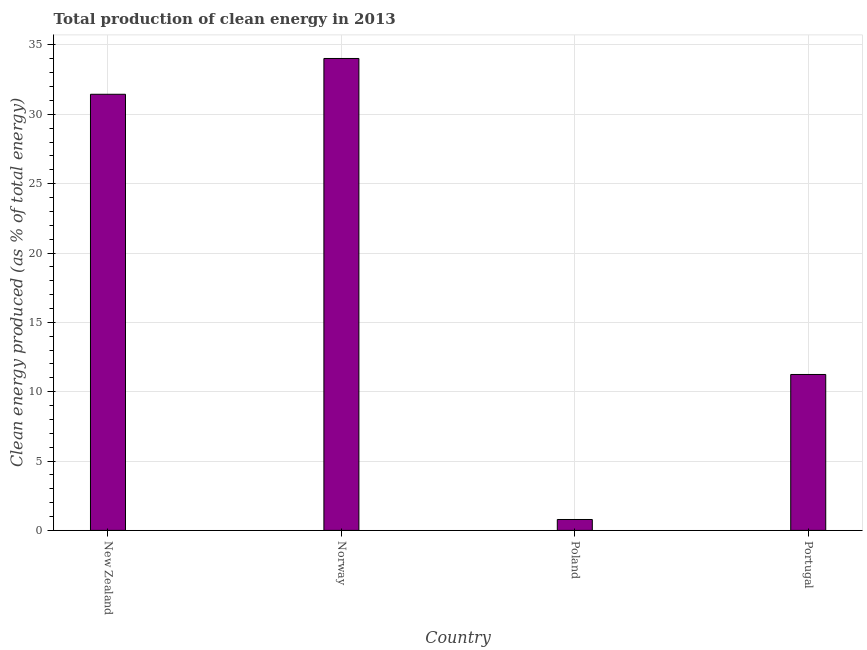What is the title of the graph?
Provide a succinct answer. Total production of clean energy in 2013. What is the label or title of the Y-axis?
Keep it short and to the point. Clean energy produced (as % of total energy). What is the production of clean energy in New Zealand?
Your response must be concise. 31.45. Across all countries, what is the maximum production of clean energy?
Your answer should be compact. 34.03. Across all countries, what is the minimum production of clean energy?
Your answer should be very brief. 0.79. What is the sum of the production of clean energy?
Give a very brief answer. 77.5. What is the difference between the production of clean energy in Norway and Poland?
Your answer should be compact. 33.24. What is the average production of clean energy per country?
Offer a very short reply. 19.38. What is the median production of clean energy?
Provide a succinct answer. 21.34. What is the ratio of the production of clean energy in New Zealand to that in Poland?
Provide a succinct answer. 39.99. Is the production of clean energy in New Zealand less than that in Poland?
Give a very brief answer. No. What is the difference between the highest and the second highest production of clean energy?
Make the answer very short. 2.58. Is the sum of the production of clean energy in New Zealand and Poland greater than the maximum production of clean energy across all countries?
Your answer should be compact. No. What is the difference between the highest and the lowest production of clean energy?
Your response must be concise. 33.24. In how many countries, is the production of clean energy greater than the average production of clean energy taken over all countries?
Your answer should be very brief. 2. How many bars are there?
Ensure brevity in your answer.  4. Are all the bars in the graph horizontal?
Offer a terse response. No. What is the Clean energy produced (as % of total energy) of New Zealand?
Provide a short and direct response. 31.45. What is the Clean energy produced (as % of total energy) in Norway?
Offer a terse response. 34.03. What is the Clean energy produced (as % of total energy) in Poland?
Your answer should be very brief. 0.79. What is the Clean energy produced (as % of total energy) of Portugal?
Ensure brevity in your answer.  11.24. What is the difference between the Clean energy produced (as % of total energy) in New Zealand and Norway?
Keep it short and to the point. -2.58. What is the difference between the Clean energy produced (as % of total energy) in New Zealand and Poland?
Keep it short and to the point. 30.66. What is the difference between the Clean energy produced (as % of total energy) in New Zealand and Portugal?
Your response must be concise. 20.2. What is the difference between the Clean energy produced (as % of total energy) in Norway and Poland?
Provide a short and direct response. 33.24. What is the difference between the Clean energy produced (as % of total energy) in Norway and Portugal?
Your answer should be very brief. 22.79. What is the difference between the Clean energy produced (as % of total energy) in Poland and Portugal?
Your answer should be compact. -10.46. What is the ratio of the Clean energy produced (as % of total energy) in New Zealand to that in Norway?
Make the answer very short. 0.92. What is the ratio of the Clean energy produced (as % of total energy) in New Zealand to that in Poland?
Provide a short and direct response. 39.99. What is the ratio of the Clean energy produced (as % of total energy) in New Zealand to that in Portugal?
Provide a succinct answer. 2.8. What is the ratio of the Clean energy produced (as % of total energy) in Norway to that in Poland?
Offer a very short reply. 43.27. What is the ratio of the Clean energy produced (as % of total energy) in Norway to that in Portugal?
Offer a very short reply. 3.03. What is the ratio of the Clean energy produced (as % of total energy) in Poland to that in Portugal?
Offer a very short reply. 0.07. 